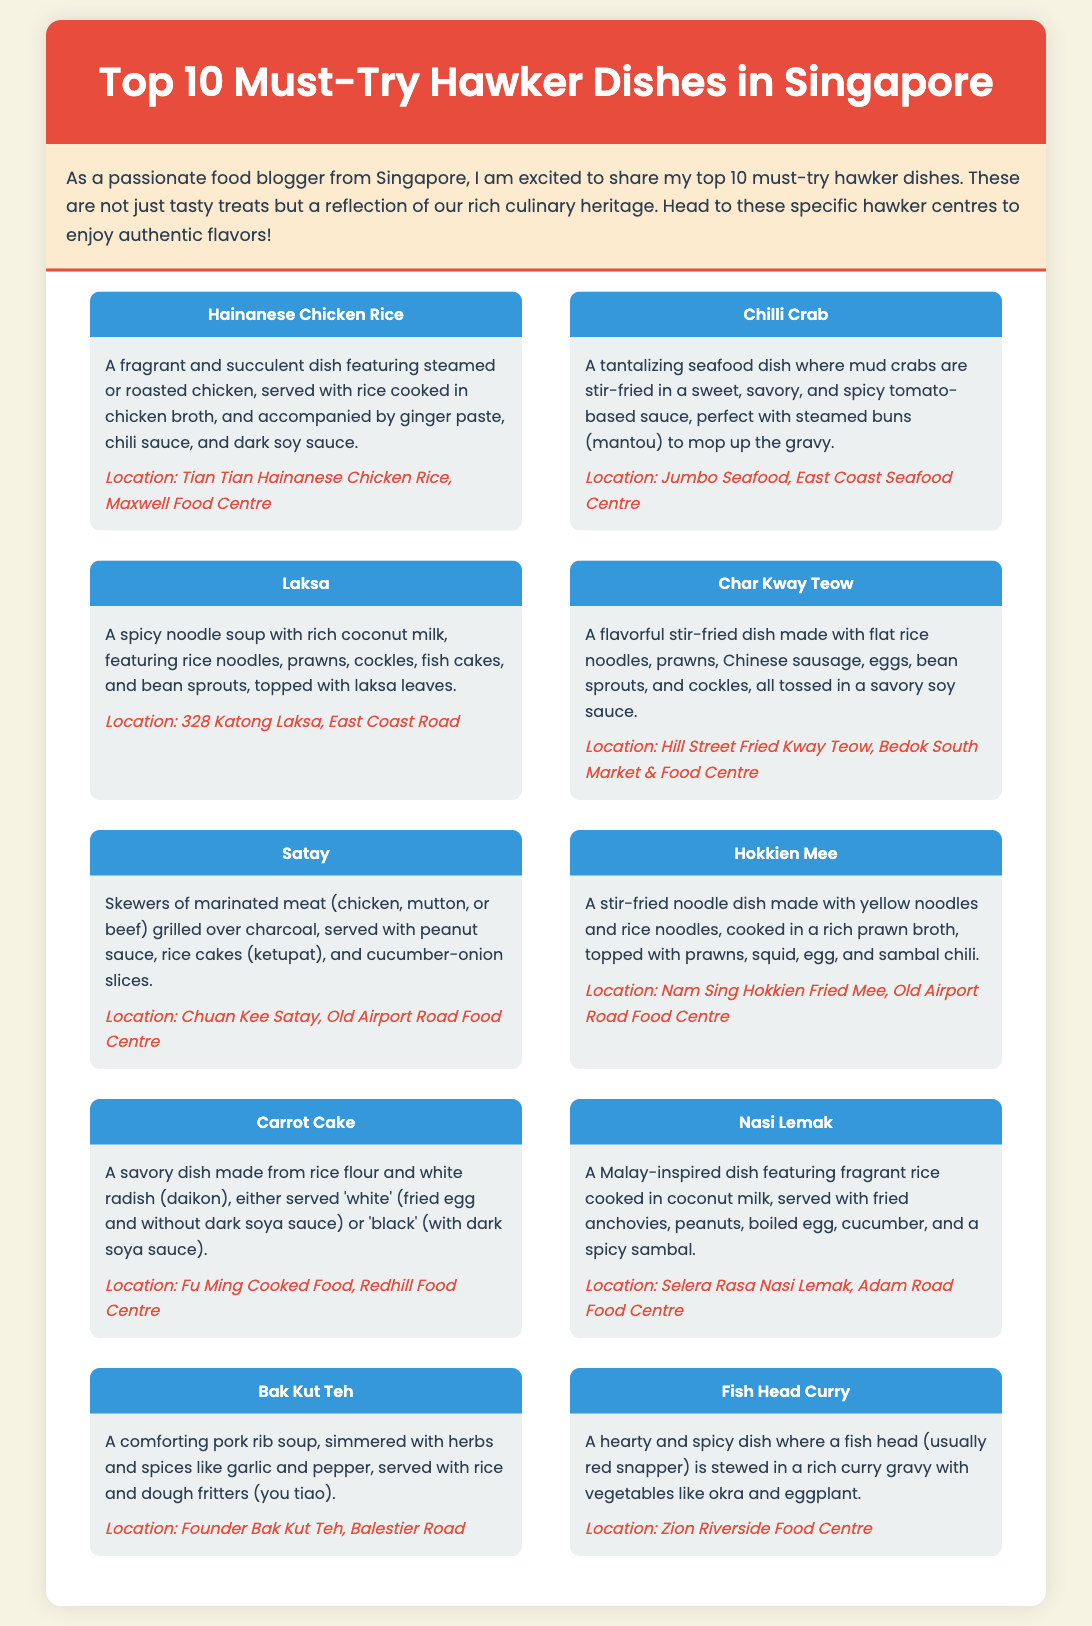what is the first dish listed? The first dish listed in the infographic is Hainanese Chicken Rice.
Answer: Hainanese Chicken Rice where can you find Chilli Crab? The document specifies the location for Chilli Crab as Jumbo Seafood, East Coast Seafood Centre.
Answer: Jumbo Seafood, East Coast Seafood Centre how many dishes are mentioned in total? There are a total of 10 dishes mentioned in the document.
Answer: 10 which dish contains rice noodles and prawns? The dish that contains rice noodles and prawns is Laksa.
Answer: Laksa what is the main ingredient in Nasi Lemak? Nasi Lemak features fragrant rice as its main ingredient.
Answer: fragrant rice which dish is served with peanut sauce? The dish served with peanut sauce is Satay.
Answer: Satay what type of soup is Bak Kut Teh? Bak Kut Teh is a pork rib soup.
Answer: pork rib soup what two elements distinguish white and black Carrot Cake? White Carrot Cake is without dark soy sauce, while black is with it.
Answer: dark soy sauce 